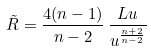Convert formula to latex. <formula><loc_0><loc_0><loc_500><loc_500>\tilde { R } = \frac { 4 ( n - 1 ) } { n - 2 } \, \frac { L u } { u ^ { \frac { n + 2 } { n - 2 } } }</formula> 